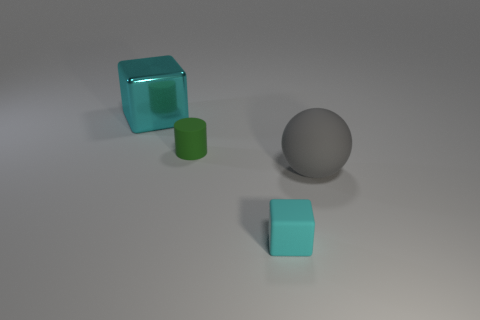Is there anything else that has the same material as the big block?
Offer a very short reply. No. What material is the small thing that is in front of the big object that is in front of the tiny cylinder made of?
Your answer should be compact. Rubber. Is there a cylinder that has the same material as the tiny cyan object?
Your answer should be very brief. Yes. Are there any green objects right of the cyan object in front of the metallic object?
Offer a terse response. No. What is the block that is behind the small rubber cylinder made of?
Ensure brevity in your answer.  Metal. Do the tiny cyan thing and the large cyan object have the same shape?
Provide a succinct answer. Yes. What is the color of the metallic block that is left of the cube to the right of the object on the left side of the small cylinder?
Ensure brevity in your answer.  Cyan. What number of tiny cyan rubber objects have the same shape as the cyan metallic object?
Keep it short and to the point. 1. There is a rubber object left of the cube that is in front of the big gray matte ball; what size is it?
Ensure brevity in your answer.  Small. Do the gray rubber ball and the cyan metal cube have the same size?
Your answer should be compact. Yes. 